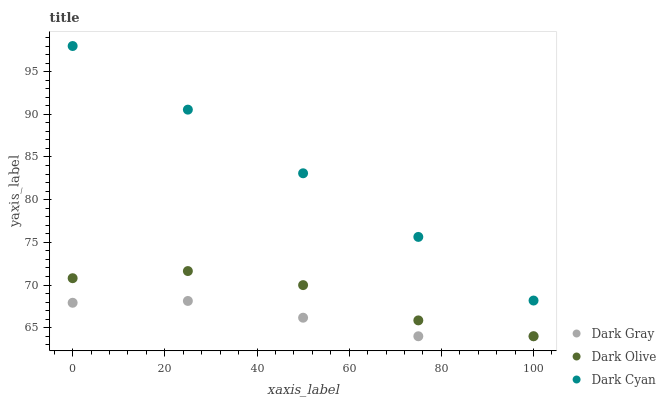Does Dark Gray have the minimum area under the curve?
Answer yes or no. Yes. Does Dark Cyan have the maximum area under the curve?
Answer yes or no. Yes. Does Dark Olive have the minimum area under the curve?
Answer yes or no. No. Does Dark Olive have the maximum area under the curve?
Answer yes or no. No. Is Dark Cyan the smoothest?
Answer yes or no. Yes. Is Dark Olive the roughest?
Answer yes or no. Yes. Is Dark Olive the smoothest?
Answer yes or no. No. Is Dark Cyan the roughest?
Answer yes or no. No. Does Dark Gray have the lowest value?
Answer yes or no. Yes. Does Dark Cyan have the lowest value?
Answer yes or no. No. Does Dark Cyan have the highest value?
Answer yes or no. Yes. Does Dark Olive have the highest value?
Answer yes or no. No. Is Dark Gray less than Dark Cyan?
Answer yes or no. Yes. Is Dark Cyan greater than Dark Olive?
Answer yes or no. Yes. Does Dark Gray intersect Dark Olive?
Answer yes or no. Yes. Is Dark Gray less than Dark Olive?
Answer yes or no. No. Is Dark Gray greater than Dark Olive?
Answer yes or no. No. Does Dark Gray intersect Dark Cyan?
Answer yes or no. No. 